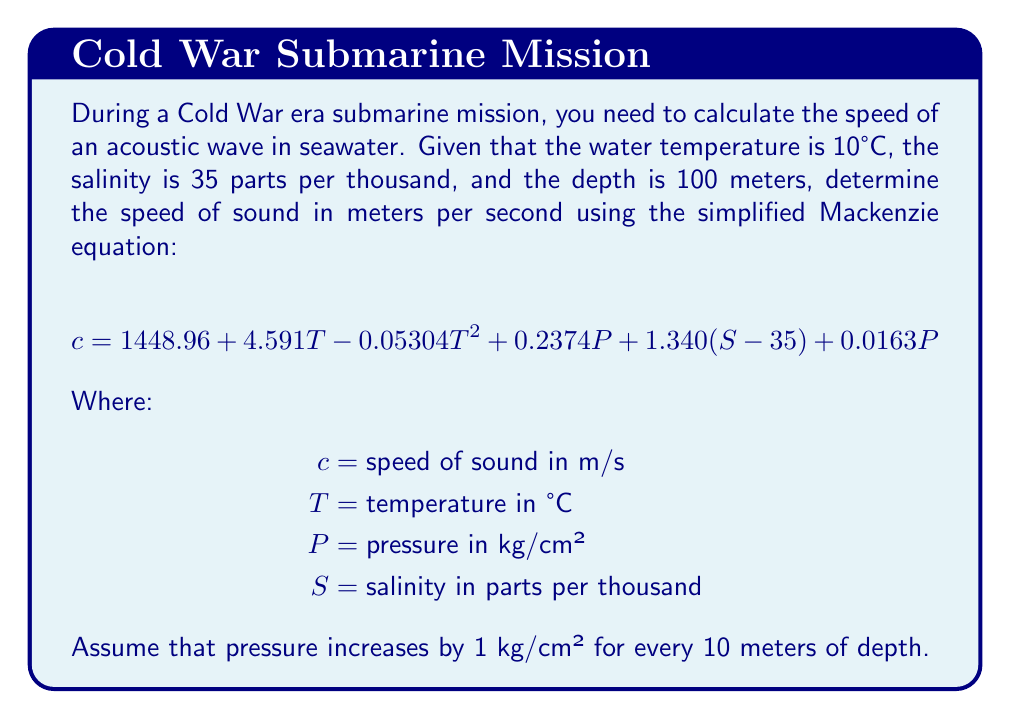Can you solve this math problem? To solve this problem, we'll follow these steps:

1. Identify the given values:
   $T = 10°C$
   $S = 35$ parts per thousand
   Depth = 100 meters

2. Calculate the pressure $P$:
   $P = \frac{100 \text{ meters}}{10 \text{ meters/kg/cm²}} = 10 \text{ kg/cm²}$

3. Substitute the values into the Mackenzie equation:

   $$c = 1448.96 + 4.591(10) - 0.05304(10)^2 + 0.2374(10) + 1.340(35-35) + 0.0163(10)$$

4. Simplify:
   $$c = 1448.96 + 45.91 - 5.304 + 2.374 + 0 + 0.163$$

5. Calculate the final result:
   $$c = 1492.103 \text{ m/s}$$
Answer: 1492.1 m/s 